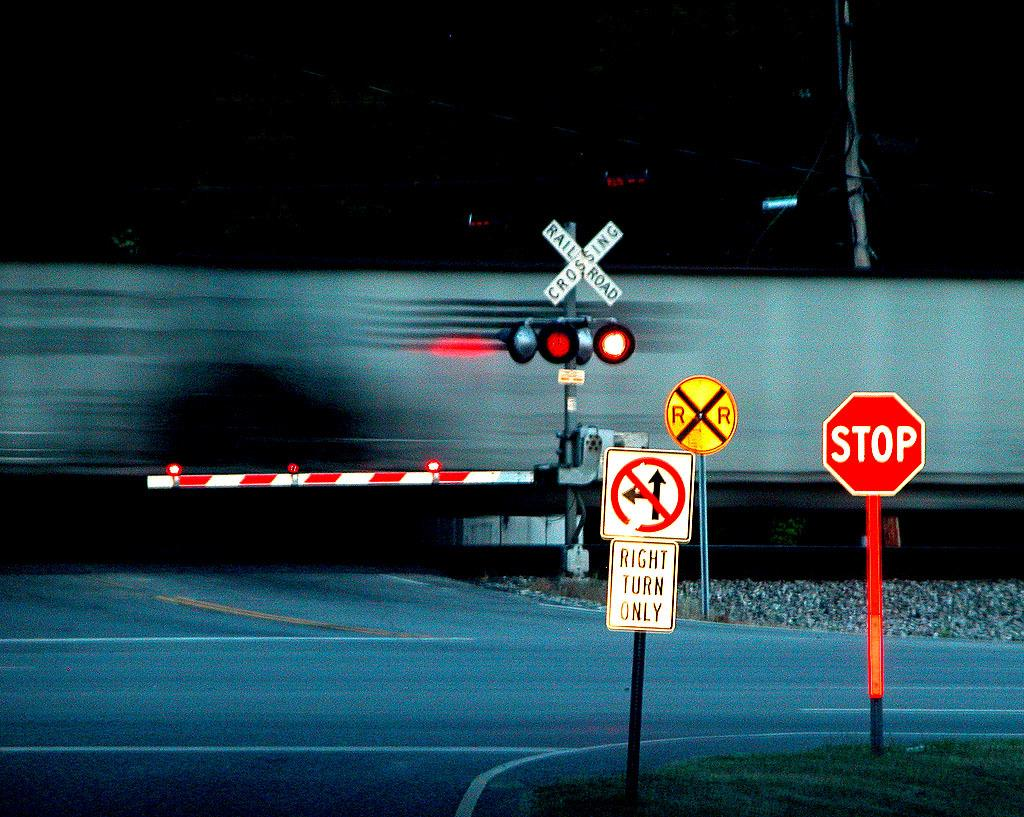Provide a one-sentence caption for the provided image. a stop sign that is in front of a large train. 